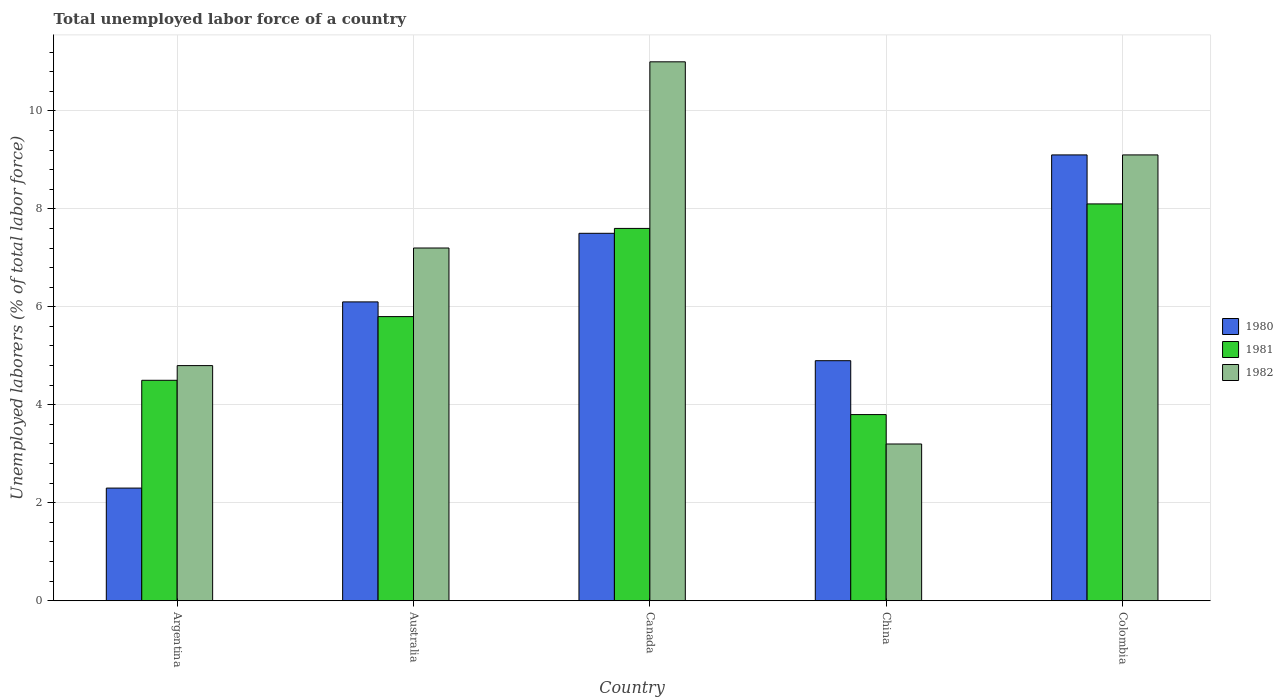How many different coloured bars are there?
Offer a very short reply. 3. How many bars are there on the 1st tick from the left?
Provide a short and direct response. 3. What is the total unemployed labor force in 1981 in Colombia?
Ensure brevity in your answer.  8.1. Across all countries, what is the maximum total unemployed labor force in 1982?
Make the answer very short. 11. Across all countries, what is the minimum total unemployed labor force in 1981?
Make the answer very short. 3.8. What is the total total unemployed labor force in 1980 in the graph?
Give a very brief answer. 29.9. What is the difference between the total unemployed labor force in 1982 in Argentina and that in Colombia?
Ensure brevity in your answer.  -4.3. What is the difference between the total unemployed labor force in 1981 in China and the total unemployed labor force in 1980 in Australia?
Ensure brevity in your answer.  -2.3. What is the average total unemployed labor force in 1981 per country?
Your response must be concise. 5.96. What is the difference between the total unemployed labor force of/in 1982 and total unemployed labor force of/in 1980 in Argentina?
Ensure brevity in your answer.  2.5. What is the ratio of the total unemployed labor force in 1980 in Argentina to that in China?
Provide a short and direct response. 0.47. Is the difference between the total unemployed labor force in 1982 in Argentina and Colombia greater than the difference between the total unemployed labor force in 1980 in Argentina and Colombia?
Make the answer very short. Yes. What is the difference between the highest and the second highest total unemployed labor force in 1980?
Offer a terse response. 3. What is the difference between the highest and the lowest total unemployed labor force in 1980?
Your answer should be compact. 6.8. In how many countries, is the total unemployed labor force in 1980 greater than the average total unemployed labor force in 1980 taken over all countries?
Ensure brevity in your answer.  3. What does the 2nd bar from the right in China represents?
Offer a terse response. 1981. What is the difference between two consecutive major ticks on the Y-axis?
Provide a short and direct response. 2. Does the graph contain any zero values?
Give a very brief answer. No. Where does the legend appear in the graph?
Your response must be concise. Center right. How are the legend labels stacked?
Ensure brevity in your answer.  Vertical. What is the title of the graph?
Provide a succinct answer. Total unemployed labor force of a country. Does "2002" appear as one of the legend labels in the graph?
Offer a very short reply. No. What is the label or title of the Y-axis?
Give a very brief answer. Unemployed laborers (% of total labor force). What is the Unemployed laborers (% of total labor force) in 1980 in Argentina?
Your answer should be compact. 2.3. What is the Unemployed laborers (% of total labor force) in 1981 in Argentina?
Your answer should be compact. 4.5. What is the Unemployed laborers (% of total labor force) in 1982 in Argentina?
Give a very brief answer. 4.8. What is the Unemployed laborers (% of total labor force) of 1980 in Australia?
Your answer should be very brief. 6.1. What is the Unemployed laborers (% of total labor force) of 1981 in Australia?
Offer a very short reply. 5.8. What is the Unemployed laborers (% of total labor force) of 1982 in Australia?
Your answer should be compact. 7.2. What is the Unemployed laborers (% of total labor force) of 1980 in Canada?
Give a very brief answer. 7.5. What is the Unemployed laborers (% of total labor force) in 1981 in Canada?
Provide a succinct answer. 7.6. What is the Unemployed laborers (% of total labor force) of 1982 in Canada?
Ensure brevity in your answer.  11. What is the Unemployed laborers (% of total labor force) of 1980 in China?
Offer a very short reply. 4.9. What is the Unemployed laborers (% of total labor force) of 1981 in China?
Offer a very short reply. 3.8. What is the Unemployed laborers (% of total labor force) of 1982 in China?
Provide a succinct answer. 3.2. What is the Unemployed laborers (% of total labor force) in 1980 in Colombia?
Offer a very short reply. 9.1. What is the Unemployed laborers (% of total labor force) in 1981 in Colombia?
Offer a terse response. 8.1. What is the Unemployed laborers (% of total labor force) of 1982 in Colombia?
Ensure brevity in your answer.  9.1. Across all countries, what is the maximum Unemployed laborers (% of total labor force) of 1980?
Offer a terse response. 9.1. Across all countries, what is the maximum Unemployed laborers (% of total labor force) of 1981?
Your answer should be very brief. 8.1. Across all countries, what is the minimum Unemployed laborers (% of total labor force) of 1980?
Make the answer very short. 2.3. Across all countries, what is the minimum Unemployed laborers (% of total labor force) of 1981?
Provide a succinct answer. 3.8. Across all countries, what is the minimum Unemployed laborers (% of total labor force) of 1982?
Give a very brief answer. 3.2. What is the total Unemployed laborers (% of total labor force) in 1980 in the graph?
Your answer should be very brief. 29.9. What is the total Unemployed laborers (% of total labor force) in 1981 in the graph?
Offer a very short reply. 29.8. What is the total Unemployed laborers (% of total labor force) of 1982 in the graph?
Give a very brief answer. 35.3. What is the difference between the Unemployed laborers (% of total labor force) of 1980 in Argentina and that in Australia?
Your answer should be compact. -3.8. What is the difference between the Unemployed laborers (% of total labor force) of 1981 in Argentina and that in Australia?
Give a very brief answer. -1.3. What is the difference between the Unemployed laborers (% of total labor force) of 1982 in Argentina and that in Australia?
Ensure brevity in your answer.  -2.4. What is the difference between the Unemployed laborers (% of total labor force) of 1982 in Argentina and that in Canada?
Ensure brevity in your answer.  -6.2. What is the difference between the Unemployed laborers (% of total labor force) of 1981 in Argentina and that in China?
Offer a terse response. 0.7. What is the difference between the Unemployed laborers (% of total labor force) in 1981 in Argentina and that in Colombia?
Your answer should be compact. -3.6. What is the difference between the Unemployed laborers (% of total labor force) in 1980 in Australia and that in China?
Provide a succinct answer. 1.2. What is the difference between the Unemployed laborers (% of total labor force) in 1981 in Australia and that in China?
Keep it short and to the point. 2. What is the difference between the Unemployed laborers (% of total labor force) of 1982 in Australia and that in China?
Provide a short and direct response. 4. What is the difference between the Unemployed laborers (% of total labor force) in 1980 in Australia and that in Colombia?
Provide a short and direct response. -3. What is the difference between the Unemployed laborers (% of total labor force) of 1982 in Australia and that in Colombia?
Your answer should be compact. -1.9. What is the difference between the Unemployed laborers (% of total labor force) of 1980 in Canada and that in China?
Provide a succinct answer. 2.6. What is the difference between the Unemployed laborers (% of total labor force) of 1982 in Canada and that in Colombia?
Your response must be concise. 1.9. What is the difference between the Unemployed laborers (% of total labor force) of 1981 in China and that in Colombia?
Your response must be concise. -4.3. What is the difference between the Unemployed laborers (% of total labor force) in 1982 in China and that in Colombia?
Your answer should be very brief. -5.9. What is the difference between the Unemployed laborers (% of total labor force) of 1980 in Argentina and the Unemployed laborers (% of total labor force) of 1982 in Canada?
Make the answer very short. -8.7. What is the difference between the Unemployed laborers (% of total labor force) in 1981 in Argentina and the Unemployed laborers (% of total labor force) in 1982 in Canada?
Your answer should be very brief. -6.5. What is the difference between the Unemployed laborers (% of total labor force) in 1980 in Argentina and the Unemployed laborers (% of total labor force) in 1981 in China?
Offer a very short reply. -1.5. What is the difference between the Unemployed laborers (% of total labor force) in 1981 in Argentina and the Unemployed laborers (% of total labor force) in 1982 in China?
Provide a short and direct response. 1.3. What is the difference between the Unemployed laborers (% of total labor force) of 1981 in Australia and the Unemployed laborers (% of total labor force) of 1982 in Canada?
Ensure brevity in your answer.  -5.2. What is the difference between the Unemployed laborers (% of total labor force) in 1980 in Australia and the Unemployed laborers (% of total labor force) in 1982 in China?
Your answer should be compact. 2.9. What is the difference between the Unemployed laborers (% of total labor force) of 1980 in Australia and the Unemployed laborers (% of total labor force) of 1981 in Colombia?
Keep it short and to the point. -2. What is the difference between the Unemployed laborers (% of total labor force) in 1980 in Canada and the Unemployed laborers (% of total labor force) in 1981 in China?
Keep it short and to the point. 3.7. What is the difference between the Unemployed laborers (% of total labor force) of 1980 in Canada and the Unemployed laborers (% of total labor force) of 1981 in Colombia?
Keep it short and to the point. -0.6. What is the average Unemployed laborers (% of total labor force) in 1980 per country?
Offer a terse response. 5.98. What is the average Unemployed laborers (% of total labor force) of 1981 per country?
Your answer should be compact. 5.96. What is the average Unemployed laborers (% of total labor force) of 1982 per country?
Your answer should be compact. 7.06. What is the difference between the Unemployed laborers (% of total labor force) in 1980 and Unemployed laborers (% of total labor force) in 1981 in Australia?
Provide a short and direct response. 0.3. What is the difference between the Unemployed laborers (% of total labor force) of 1980 and Unemployed laborers (% of total labor force) of 1982 in Canada?
Provide a short and direct response. -3.5. What is the difference between the Unemployed laborers (% of total labor force) in 1980 and Unemployed laborers (% of total labor force) in 1981 in China?
Keep it short and to the point. 1.1. What is the difference between the Unemployed laborers (% of total labor force) in 1981 and Unemployed laborers (% of total labor force) in 1982 in China?
Your answer should be compact. 0.6. What is the difference between the Unemployed laborers (% of total labor force) of 1980 and Unemployed laborers (% of total labor force) of 1981 in Colombia?
Give a very brief answer. 1. What is the ratio of the Unemployed laborers (% of total labor force) in 1980 in Argentina to that in Australia?
Your answer should be very brief. 0.38. What is the ratio of the Unemployed laborers (% of total labor force) of 1981 in Argentina to that in Australia?
Keep it short and to the point. 0.78. What is the ratio of the Unemployed laborers (% of total labor force) of 1980 in Argentina to that in Canada?
Make the answer very short. 0.31. What is the ratio of the Unemployed laborers (% of total labor force) of 1981 in Argentina to that in Canada?
Offer a terse response. 0.59. What is the ratio of the Unemployed laborers (% of total labor force) of 1982 in Argentina to that in Canada?
Ensure brevity in your answer.  0.44. What is the ratio of the Unemployed laborers (% of total labor force) of 1980 in Argentina to that in China?
Your answer should be compact. 0.47. What is the ratio of the Unemployed laborers (% of total labor force) of 1981 in Argentina to that in China?
Ensure brevity in your answer.  1.18. What is the ratio of the Unemployed laborers (% of total labor force) in 1980 in Argentina to that in Colombia?
Offer a terse response. 0.25. What is the ratio of the Unemployed laborers (% of total labor force) of 1981 in Argentina to that in Colombia?
Offer a terse response. 0.56. What is the ratio of the Unemployed laborers (% of total labor force) of 1982 in Argentina to that in Colombia?
Keep it short and to the point. 0.53. What is the ratio of the Unemployed laborers (% of total labor force) in 1980 in Australia to that in Canada?
Make the answer very short. 0.81. What is the ratio of the Unemployed laborers (% of total labor force) of 1981 in Australia to that in Canada?
Your response must be concise. 0.76. What is the ratio of the Unemployed laborers (% of total labor force) of 1982 in Australia to that in Canada?
Keep it short and to the point. 0.65. What is the ratio of the Unemployed laborers (% of total labor force) of 1980 in Australia to that in China?
Offer a very short reply. 1.24. What is the ratio of the Unemployed laborers (% of total labor force) in 1981 in Australia to that in China?
Make the answer very short. 1.53. What is the ratio of the Unemployed laborers (% of total labor force) of 1982 in Australia to that in China?
Make the answer very short. 2.25. What is the ratio of the Unemployed laborers (% of total labor force) in 1980 in Australia to that in Colombia?
Your answer should be very brief. 0.67. What is the ratio of the Unemployed laborers (% of total labor force) in 1981 in Australia to that in Colombia?
Offer a terse response. 0.72. What is the ratio of the Unemployed laborers (% of total labor force) of 1982 in Australia to that in Colombia?
Ensure brevity in your answer.  0.79. What is the ratio of the Unemployed laborers (% of total labor force) in 1980 in Canada to that in China?
Keep it short and to the point. 1.53. What is the ratio of the Unemployed laborers (% of total labor force) in 1981 in Canada to that in China?
Provide a succinct answer. 2. What is the ratio of the Unemployed laborers (% of total labor force) of 1982 in Canada to that in China?
Your answer should be compact. 3.44. What is the ratio of the Unemployed laborers (% of total labor force) in 1980 in Canada to that in Colombia?
Your answer should be very brief. 0.82. What is the ratio of the Unemployed laborers (% of total labor force) of 1981 in Canada to that in Colombia?
Provide a succinct answer. 0.94. What is the ratio of the Unemployed laborers (% of total labor force) of 1982 in Canada to that in Colombia?
Provide a short and direct response. 1.21. What is the ratio of the Unemployed laborers (% of total labor force) in 1980 in China to that in Colombia?
Your answer should be very brief. 0.54. What is the ratio of the Unemployed laborers (% of total labor force) of 1981 in China to that in Colombia?
Your response must be concise. 0.47. What is the ratio of the Unemployed laborers (% of total labor force) in 1982 in China to that in Colombia?
Your response must be concise. 0.35. What is the difference between the highest and the second highest Unemployed laborers (% of total labor force) in 1981?
Offer a very short reply. 0.5. What is the difference between the highest and the second highest Unemployed laborers (% of total labor force) of 1982?
Provide a succinct answer. 1.9. 